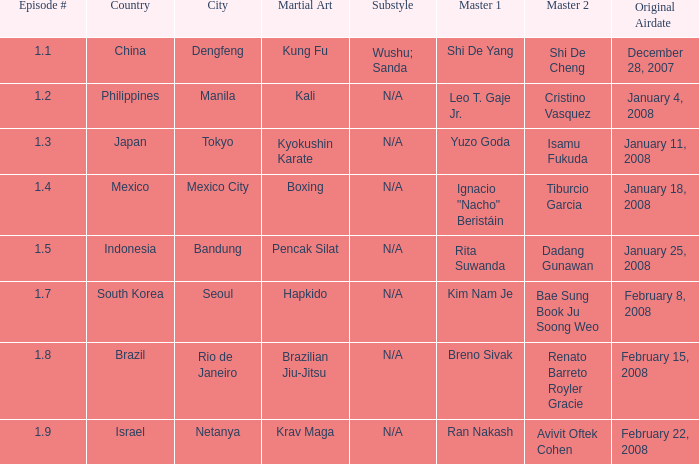In which country is the city of Netanya? Israel. 